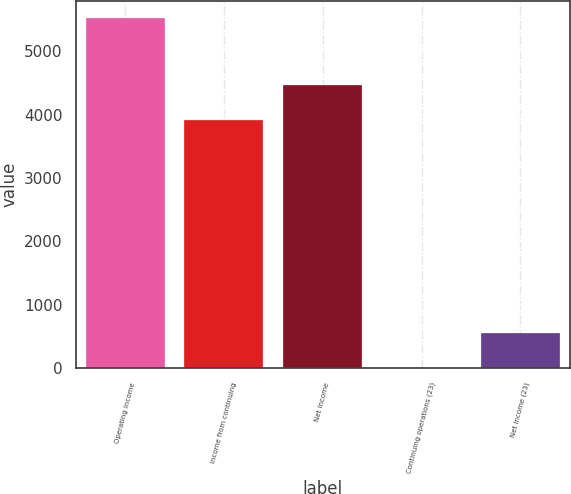Convert chart. <chart><loc_0><loc_0><loc_500><loc_500><bar_chart><fcel>Operating income<fcel>Income from continuing<fcel>Net income<fcel>Continuing operations (23)<fcel>Net income (23)<nl><fcel>5520<fcel>3914<fcel>4465.68<fcel>3.23<fcel>554.91<nl></chart> 